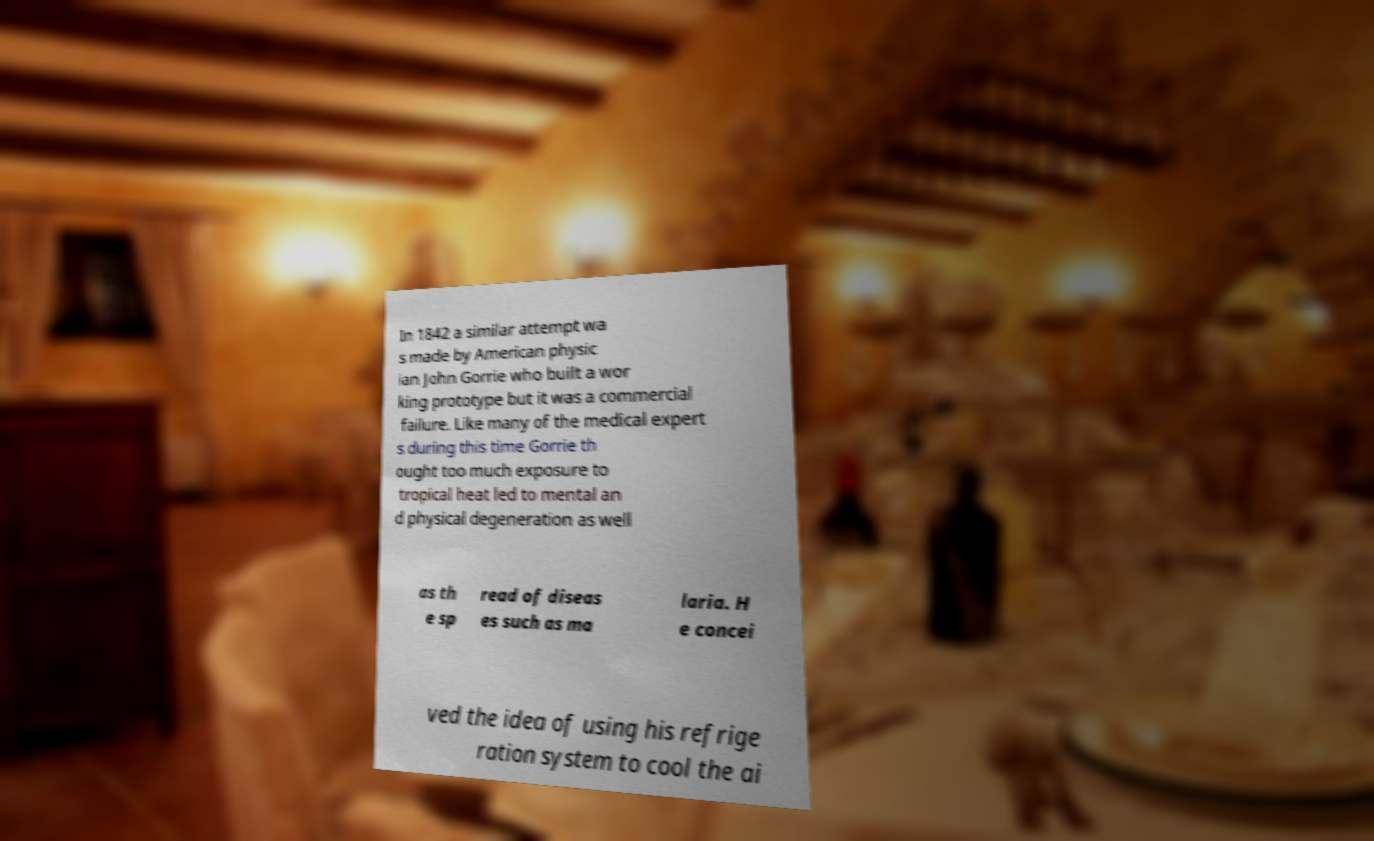I need the written content from this picture converted into text. Can you do that? In 1842 a similar attempt wa s made by American physic ian John Gorrie who built a wor king prototype but it was a commercial failure. Like many of the medical expert s during this time Gorrie th ought too much exposure to tropical heat led to mental an d physical degeneration as well as th e sp read of diseas es such as ma laria. H e concei ved the idea of using his refrige ration system to cool the ai 